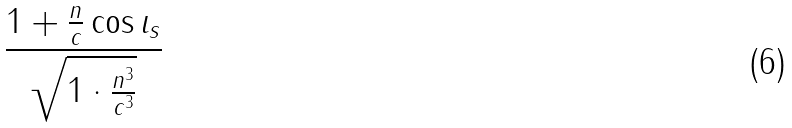<formula> <loc_0><loc_0><loc_500><loc_500>\frac { 1 + \frac { n } { c } \cos \iota _ { s } } { \sqrt { 1 \cdot \frac { n ^ { 3 } } { c ^ { 3 } } } }</formula> 